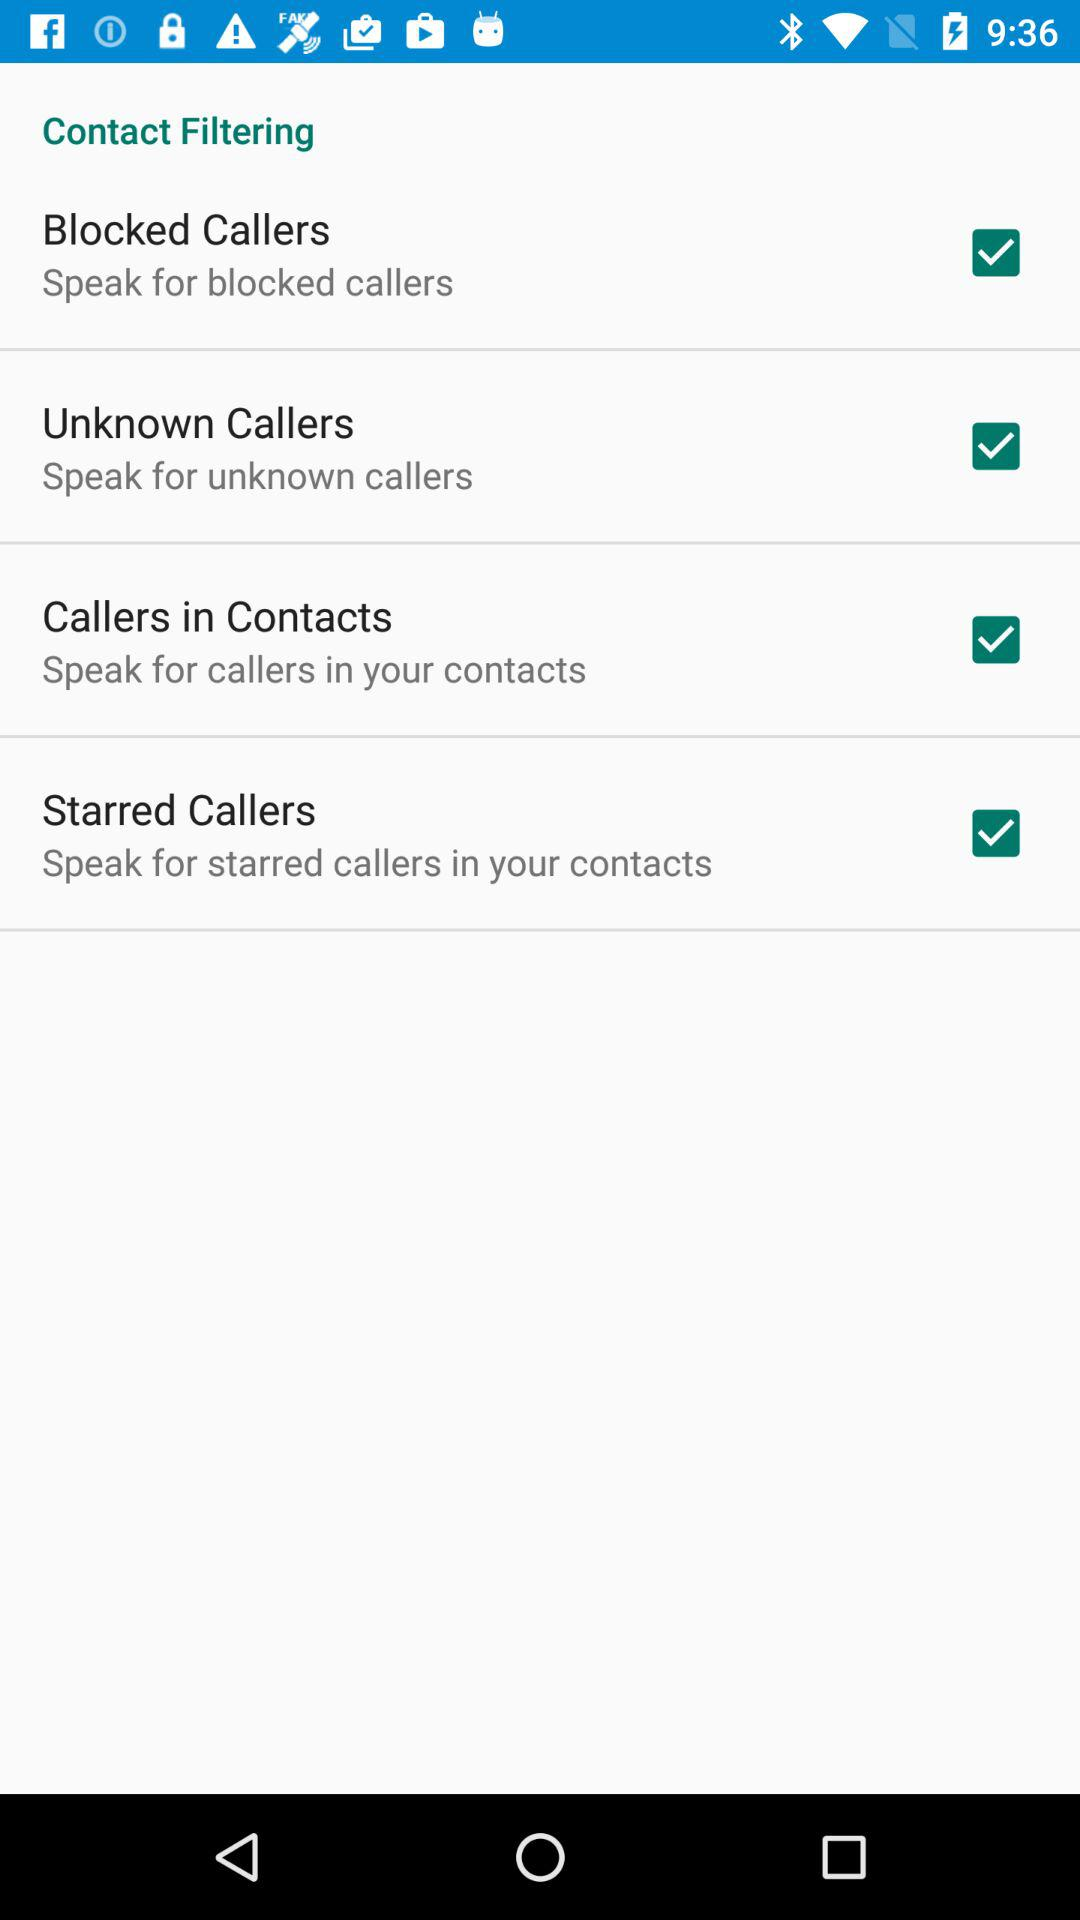What type of filtering is mentioned? The mentioned type of filtering is "Contact Filtering". 